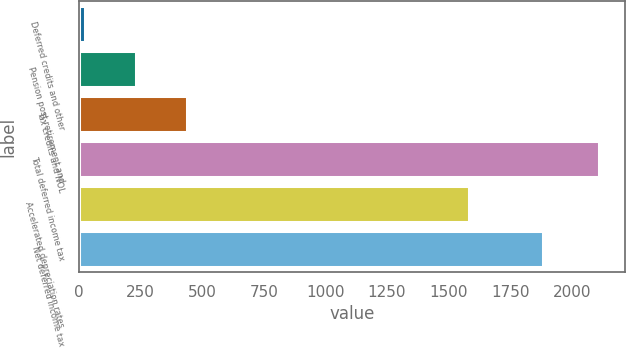Convert chart. <chart><loc_0><loc_0><loc_500><loc_500><bar_chart><fcel>Deferred credits and other<fcel>Pension post-retirement and<fcel>Tax credits and NOL<fcel>Total deferred income tax<fcel>Accelerated depreciation rates<fcel>Net deferred income tax<nl><fcel>23<fcel>231.7<fcel>440.4<fcel>2110<fcel>1583<fcel>1883<nl></chart> 